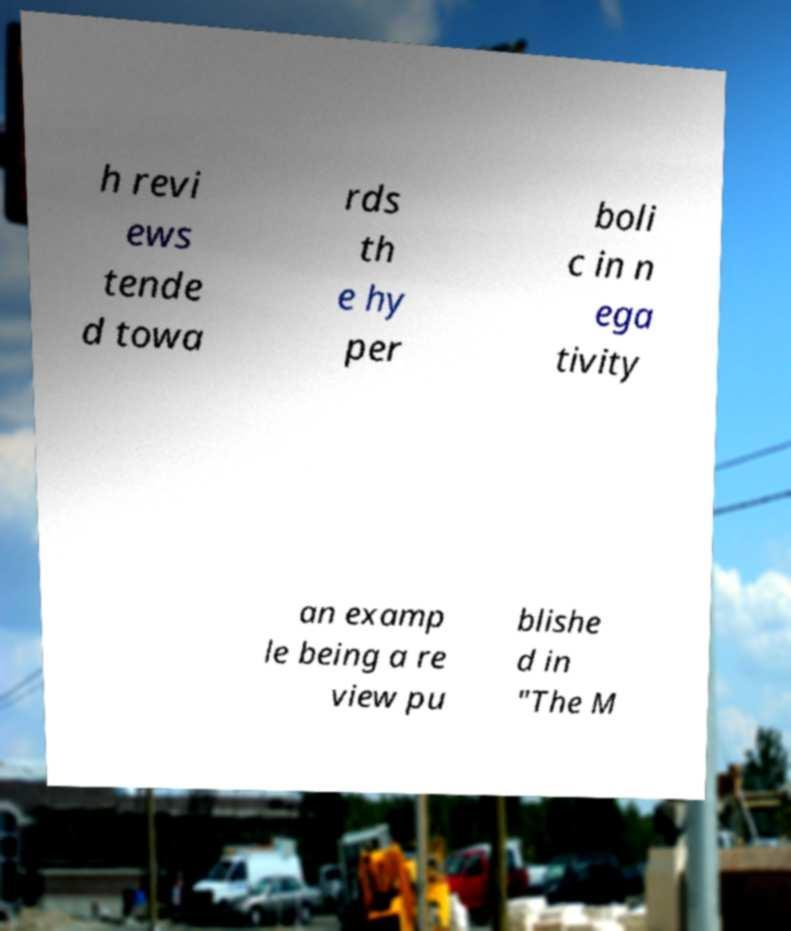Please read and relay the text visible in this image. What does it say? h revi ews tende d towa rds th e hy per boli c in n ega tivity an examp le being a re view pu blishe d in "The M 